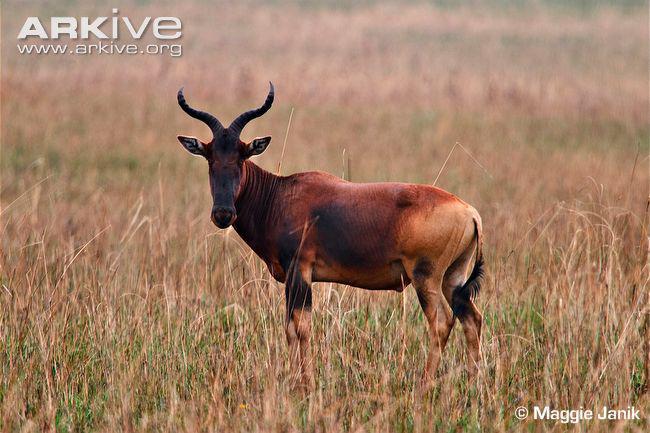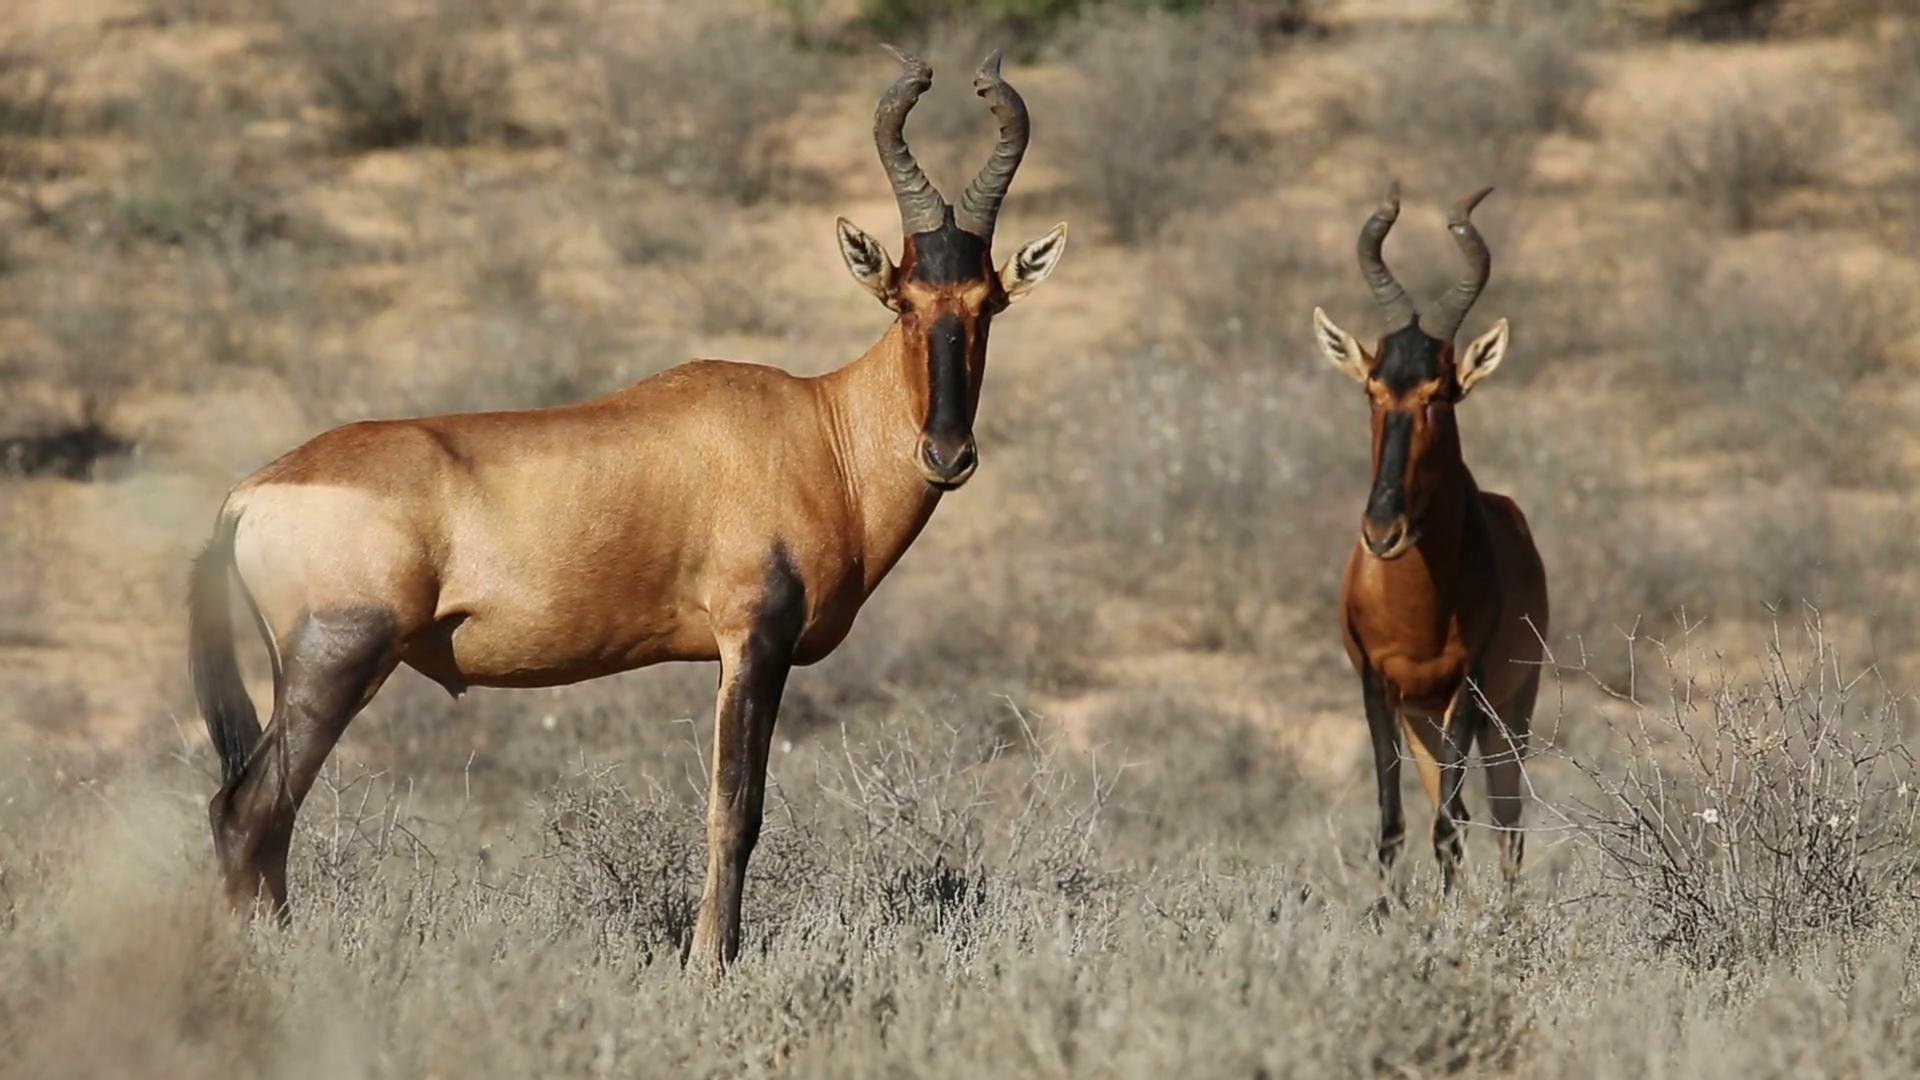The first image is the image on the left, the second image is the image on the right. Examine the images to the left and right. Is the description "A total of three animals with horns are standing still, and most have their heads turned to the camera." accurate? Answer yes or no. Yes. The first image is the image on the left, the second image is the image on the right. Assess this claim about the two images: "The left and right image contains a total of three elk and the single elk facing left.". Correct or not? Answer yes or no. Yes. 